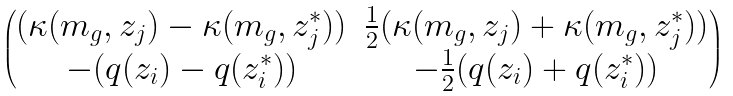<formula> <loc_0><loc_0><loc_500><loc_500>\begin{pmatrix} ( \kappa ( m _ { g } , z _ { j } ) - \kappa ( m _ { g } , z _ { j } ^ { * } ) ) & \frac { 1 } { 2 } ( \kappa ( m _ { g } , z _ { j } ) + \kappa ( m _ { g } , z _ { j } ^ { * } ) ) \\ - ( q ( z _ { i } ) - q ( z _ { i } ^ { \ast } ) ) & - \frac { 1 } { 2 } ( q ( z _ { i } ) + q ( z _ { i } ^ { \ast } ) ) \end{pmatrix}</formula> 